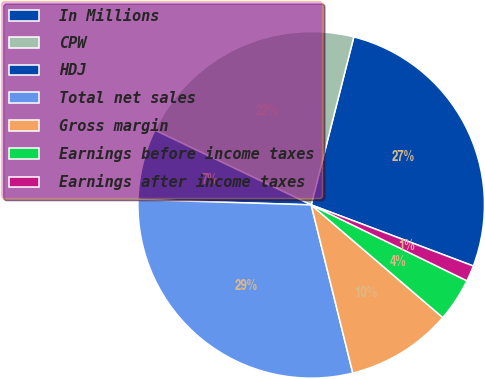Convert chart. <chart><loc_0><loc_0><loc_500><loc_500><pie_chart><fcel>In Millions<fcel>CPW<fcel>HDJ<fcel>Total net sales<fcel>Gross margin<fcel>Earnings before income taxes<fcel>Earnings after income taxes<nl><fcel>26.78%<fcel>21.86%<fcel>6.61%<fcel>29.34%<fcel>9.87%<fcel>4.05%<fcel>1.48%<nl></chart> 